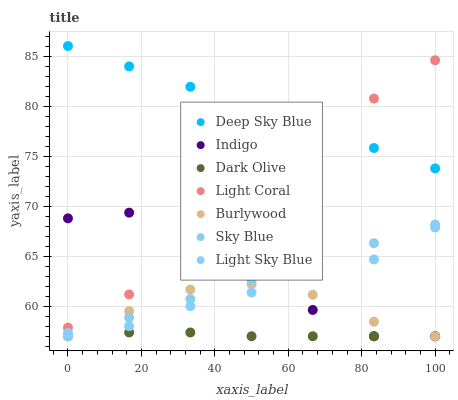Does Dark Olive have the minimum area under the curve?
Answer yes or no. Yes. Does Deep Sky Blue have the maximum area under the curve?
Answer yes or no. Yes. Does Burlywood have the minimum area under the curve?
Answer yes or no. No. Does Burlywood have the maximum area under the curve?
Answer yes or no. No. Is Sky Blue the smoothest?
Answer yes or no. Yes. Is Indigo the roughest?
Answer yes or no. Yes. Is Burlywood the smoothest?
Answer yes or no. No. Is Burlywood the roughest?
Answer yes or no. No. Does Indigo have the lowest value?
Answer yes or no. Yes. Does Light Coral have the lowest value?
Answer yes or no. No. Does Deep Sky Blue have the highest value?
Answer yes or no. Yes. Does Burlywood have the highest value?
Answer yes or no. No. Is Sky Blue less than Light Coral?
Answer yes or no. Yes. Is Deep Sky Blue greater than Dark Olive?
Answer yes or no. Yes. Does Burlywood intersect Dark Olive?
Answer yes or no. Yes. Is Burlywood less than Dark Olive?
Answer yes or no. No. Is Burlywood greater than Dark Olive?
Answer yes or no. No. Does Sky Blue intersect Light Coral?
Answer yes or no. No. 